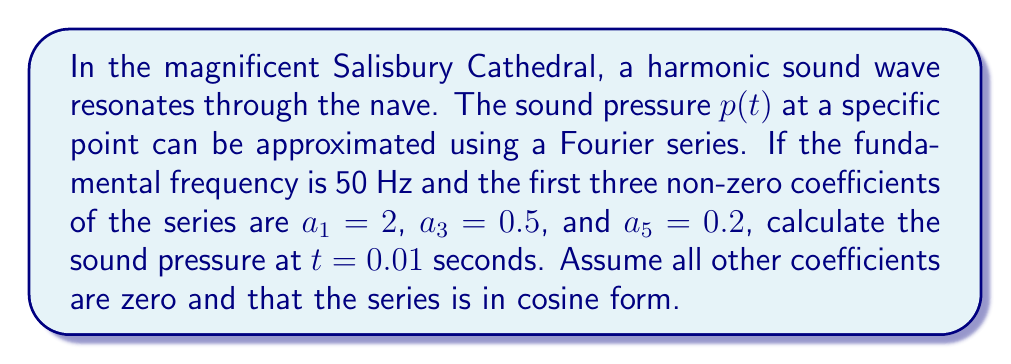Provide a solution to this math problem. Let's approach this step-by-step:

1) The general form of a Fourier cosine series is:

   $$p(t) = \frac{a_0}{2} + \sum_{n=1}^{\infty} a_n \cos(n\omega t)$$

   where $\omega = 2\pi f$ and $f$ is the fundamental frequency.

2) Given information:
   - Fundamental frequency $f = 50$ Hz
   - $a_1 = 2$, $a_3 = 0.5$, $a_5 = 0.2$, all other coefficients are zero
   - $t = 0.01$ seconds

3) Calculate $\omega$:
   $$\omega = 2\pi f = 2\pi(50) = 100\pi$$

4) Our specific Fourier series becomes:

   $$p(t) = 2\cos(100\pi t) + 0.5\cos(300\pi t) + 0.2\cos(500\pi t)$$

5) Now, let's calculate each term at $t = 0.01$:

   Term 1: $2\cos(100\pi(0.01)) = 2\cos(\pi) = -2$
   
   Term 2: $0.5\cos(300\pi(0.01)) = 0.5\cos(3\pi) = -0.5$
   
   Term 3: $0.2\cos(500\pi(0.01)) = 0.2\cos(5\pi) = 0.2$

6) Sum all terms:

   $$p(0.01) = -2 - 0.5 + 0.2 = -2.3$$

Thus, the sound pressure at $t = 0.01$ seconds is -2.3 (units would depend on how the coefficients were measured, typically Pascal).
Answer: -2.3 